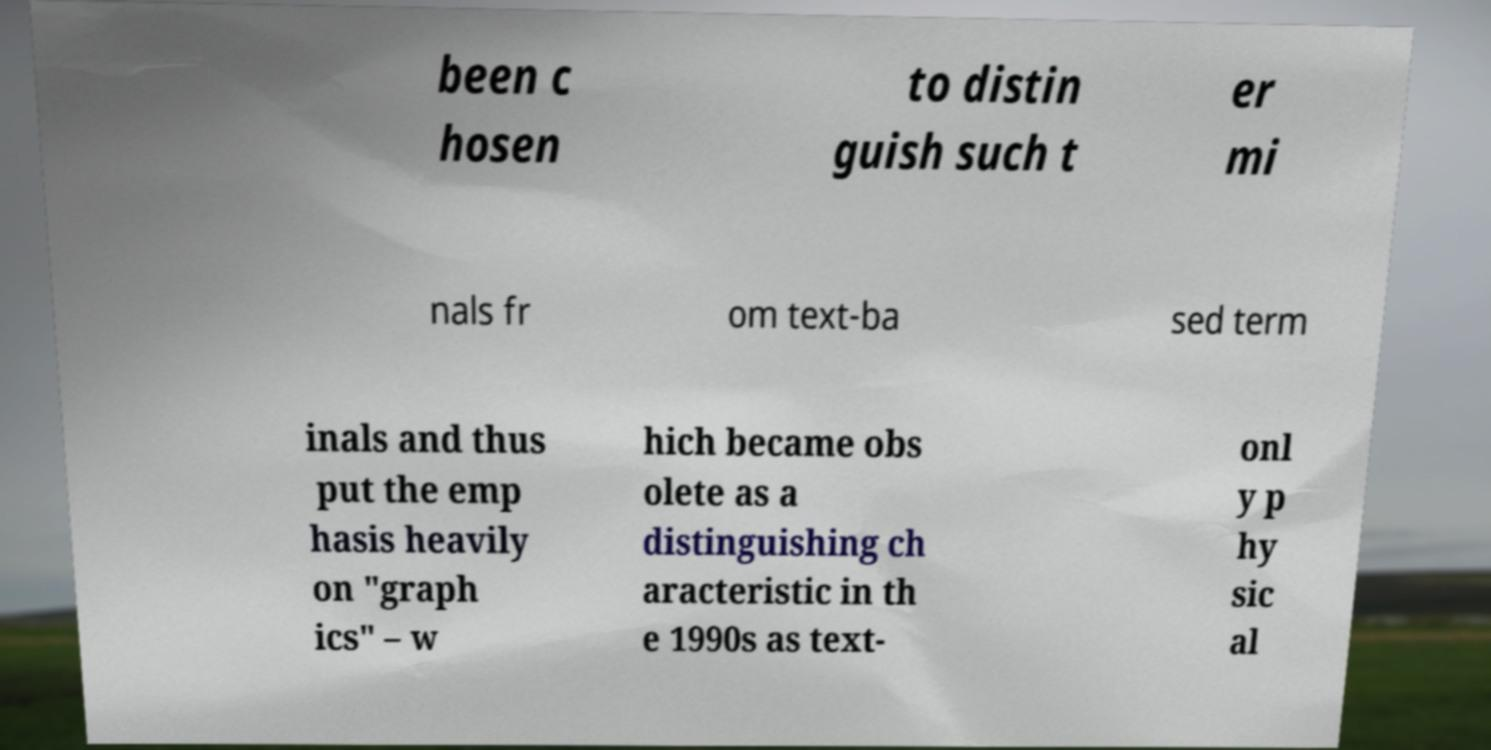For documentation purposes, I need the text within this image transcribed. Could you provide that? been c hosen to distin guish such t er mi nals fr om text-ba sed term inals and thus put the emp hasis heavily on "graph ics" – w hich became obs olete as a distinguishing ch aracteristic in th e 1990s as text- onl y p hy sic al 